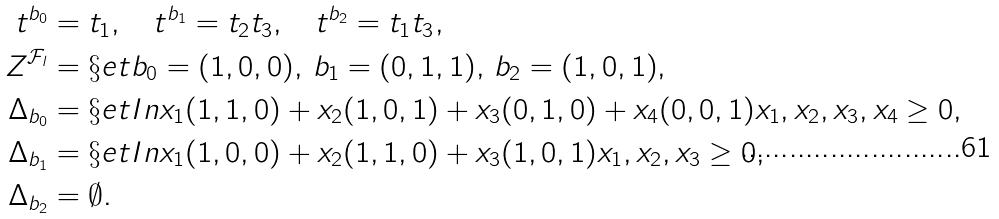Convert formula to latex. <formula><loc_0><loc_0><loc_500><loc_500>t ^ { b _ { 0 } } & = t _ { 1 } , \quad t ^ { b _ { 1 } } = t _ { 2 } t _ { 3 } , \quad t ^ { b _ { 2 } } = t _ { 1 } t _ { 3 } , \\ Z ^ { \mathcal { F } _ { l } } & = \S e t { b _ { 0 } = ( 1 , 0 , 0 ) , \, b _ { 1 } = ( 0 , 1 , 1 ) , \, b _ { 2 } = ( 1 , 0 , 1 ) } , \\ \Delta _ { b _ { 0 } } & = \S e t I n { x _ { 1 } ( 1 , 1 , 0 ) + x _ { 2 } ( 1 , 0 , 1 ) + x _ { 3 } ( 0 , 1 , 0 ) + x _ { 4 } ( 0 , 0 , 1 ) } { x _ { 1 } , x _ { 2 } , x _ { 3 } , x _ { 4 } \geq 0 } , \\ \Delta _ { b _ { 1 } } & = \S e t I n { x _ { 1 } ( 1 , 0 , 0 ) + x _ { 2 } ( 1 , 1 , 0 ) + x _ { 3 } ( 1 , 0 , 1 ) } { x _ { 1 } , x _ { 2 } , x _ { 3 } \geq 0 } , \\ \Delta _ { b _ { 2 } } & = \emptyset .</formula> 